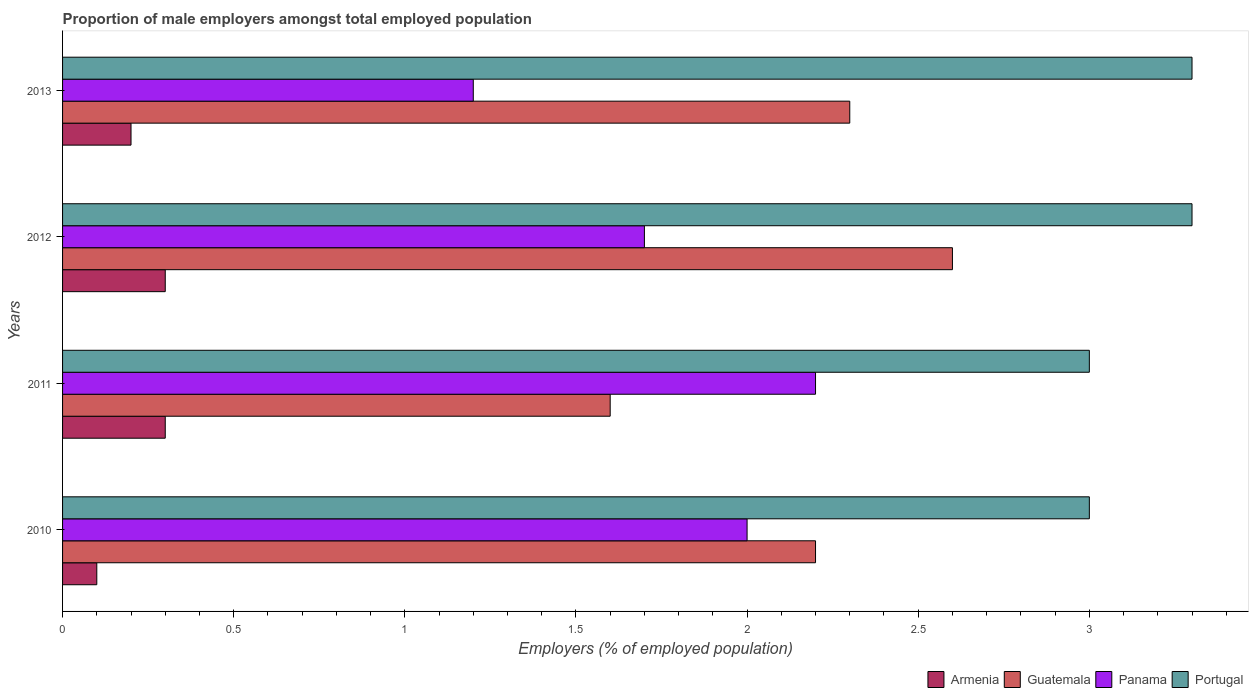Are the number of bars per tick equal to the number of legend labels?
Offer a terse response. Yes. How many bars are there on the 4th tick from the bottom?
Keep it short and to the point. 4. What is the proportion of male employers in Armenia in 2012?
Your answer should be compact. 0.3. Across all years, what is the maximum proportion of male employers in Portugal?
Make the answer very short. 3.3. Across all years, what is the minimum proportion of male employers in Panama?
Your answer should be compact. 1.2. In which year was the proportion of male employers in Armenia maximum?
Your answer should be very brief. 2011. In which year was the proportion of male employers in Panama minimum?
Give a very brief answer. 2013. What is the total proportion of male employers in Portugal in the graph?
Offer a terse response. 12.6. What is the difference between the proportion of male employers in Guatemala in 2011 and that in 2012?
Make the answer very short. -1. What is the difference between the proportion of male employers in Panama in 2011 and the proportion of male employers in Armenia in 2012?
Provide a succinct answer. 1.9. What is the average proportion of male employers in Armenia per year?
Make the answer very short. 0.23. In the year 2011, what is the difference between the proportion of male employers in Guatemala and proportion of male employers in Panama?
Give a very brief answer. -0.6. What is the ratio of the proportion of male employers in Armenia in 2012 to that in 2013?
Give a very brief answer. 1.5. Is the proportion of male employers in Portugal in 2011 less than that in 2013?
Offer a very short reply. Yes. What is the difference between the highest and the second highest proportion of male employers in Panama?
Provide a short and direct response. 0.2. What is the difference between the highest and the lowest proportion of male employers in Portugal?
Keep it short and to the point. 0.3. In how many years, is the proportion of male employers in Guatemala greater than the average proportion of male employers in Guatemala taken over all years?
Ensure brevity in your answer.  3. Is the sum of the proportion of male employers in Armenia in 2010 and 2012 greater than the maximum proportion of male employers in Guatemala across all years?
Make the answer very short. No. What does the 1st bar from the top in 2010 represents?
Your response must be concise. Portugal. What does the 3rd bar from the bottom in 2011 represents?
Offer a terse response. Panama. How many bars are there?
Your answer should be compact. 16. How many years are there in the graph?
Offer a terse response. 4. How many legend labels are there?
Offer a terse response. 4. How are the legend labels stacked?
Offer a very short reply. Horizontal. What is the title of the graph?
Make the answer very short. Proportion of male employers amongst total employed population. Does "Guam" appear as one of the legend labels in the graph?
Give a very brief answer. No. What is the label or title of the X-axis?
Your response must be concise. Employers (% of employed population). What is the Employers (% of employed population) in Armenia in 2010?
Ensure brevity in your answer.  0.1. What is the Employers (% of employed population) in Guatemala in 2010?
Give a very brief answer. 2.2. What is the Employers (% of employed population) in Panama in 2010?
Your answer should be very brief. 2. What is the Employers (% of employed population) of Armenia in 2011?
Ensure brevity in your answer.  0.3. What is the Employers (% of employed population) in Guatemala in 2011?
Make the answer very short. 1.6. What is the Employers (% of employed population) in Panama in 2011?
Offer a very short reply. 2.2. What is the Employers (% of employed population) of Armenia in 2012?
Offer a terse response. 0.3. What is the Employers (% of employed population) in Guatemala in 2012?
Your answer should be very brief. 2.6. What is the Employers (% of employed population) in Panama in 2012?
Make the answer very short. 1.7. What is the Employers (% of employed population) of Portugal in 2012?
Make the answer very short. 3.3. What is the Employers (% of employed population) in Armenia in 2013?
Offer a terse response. 0.2. What is the Employers (% of employed population) in Guatemala in 2013?
Provide a succinct answer. 2.3. What is the Employers (% of employed population) of Panama in 2013?
Provide a succinct answer. 1.2. What is the Employers (% of employed population) of Portugal in 2013?
Your answer should be very brief. 3.3. Across all years, what is the maximum Employers (% of employed population) of Armenia?
Offer a very short reply. 0.3. Across all years, what is the maximum Employers (% of employed population) of Guatemala?
Your answer should be compact. 2.6. Across all years, what is the maximum Employers (% of employed population) in Panama?
Provide a succinct answer. 2.2. Across all years, what is the maximum Employers (% of employed population) of Portugal?
Provide a succinct answer. 3.3. Across all years, what is the minimum Employers (% of employed population) in Armenia?
Give a very brief answer. 0.1. Across all years, what is the minimum Employers (% of employed population) of Guatemala?
Offer a very short reply. 1.6. Across all years, what is the minimum Employers (% of employed population) in Panama?
Offer a terse response. 1.2. What is the total Employers (% of employed population) in Guatemala in the graph?
Offer a very short reply. 8.7. What is the difference between the Employers (% of employed population) of Armenia in 2010 and that in 2012?
Offer a terse response. -0.2. What is the difference between the Employers (% of employed population) in Guatemala in 2010 and that in 2012?
Keep it short and to the point. -0.4. What is the difference between the Employers (% of employed population) in Panama in 2010 and that in 2012?
Your answer should be very brief. 0.3. What is the difference between the Employers (% of employed population) in Portugal in 2010 and that in 2012?
Keep it short and to the point. -0.3. What is the difference between the Employers (% of employed population) of Panama in 2010 and that in 2013?
Your answer should be very brief. 0.8. What is the difference between the Employers (% of employed population) of Portugal in 2010 and that in 2013?
Your answer should be compact. -0.3. What is the difference between the Employers (% of employed population) of Guatemala in 2011 and that in 2012?
Your answer should be compact. -1. What is the difference between the Employers (% of employed population) in Panama in 2011 and that in 2012?
Your response must be concise. 0.5. What is the difference between the Employers (% of employed population) of Portugal in 2011 and that in 2012?
Offer a terse response. -0.3. What is the difference between the Employers (% of employed population) in Guatemala in 2011 and that in 2013?
Ensure brevity in your answer.  -0.7. What is the difference between the Employers (% of employed population) in Portugal in 2011 and that in 2013?
Make the answer very short. -0.3. What is the difference between the Employers (% of employed population) of Armenia in 2012 and that in 2013?
Your answer should be compact. 0.1. What is the difference between the Employers (% of employed population) of Guatemala in 2012 and that in 2013?
Provide a short and direct response. 0.3. What is the difference between the Employers (% of employed population) in Armenia in 2010 and the Employers (% of employed population) in Panama in 2011?
Ensure brevity in your answer.  -2.1. What is the difference between the Employers (% of employed population) in Panama in 2010 and the Employers (% of employed population) in Portugal in 2011?
Offer a terse response. -1. What is the difference between the Employers (% of employed population) of Armenia in 2010 and the Employers (% of employed population) of Guatemala in 2012?
Provide a short and direct response. -2.5. What is the difference between the Employers (% of employed population) of Armenia in 2010 and the Employers (% of employed population) of Panama in 2012?
Offer a very short reply. -1.6. What is the difference between the Employers (% of employed population) of Guatemala in 2010 and the Employers (% of employed population) of Panama in 2012?
Provide a succinct answer. 0.5. What is the difference between the Employers (% of employed population) in Armenia in 2010 and the Employers (% of employed population) in Guatemala in 2013?
Ensure brevity in your answer.  -2.2. What is the difference between the Employers (% of employed population) of Armenia in 2010 and the Employers (% of employed population) of Panama in 2013?
Make the answer very short. -1.1. What is the difference between the Employers (% of employed population) in Guatemala in 2010 and the Employers (% of employed population) in Panama in 2013?
Ensure brevity in your answer.  1. What is the difference between the Employers (% of employed population) of Guatemala in 2010 and the Employers (% of employed population) of Portugal in 2013?
Provide a succinct answer. -1.1. What is the difference between the Employers (% of employed population) in Panama in 2010 and the Employers (% of employed population) in Portugal in 2013?
Offer a very short reply. -1.3. What is the difference between the Employers (% of employed population) of Guatemala in 2011 and the Employers (% of employed population) of Panama in 2012?
Your answer should be compact. -0.1. What is the difference between the Employers (% of employed population) in Guatemala in 2011 and the Employers (% of employed population) in Portugal in 2012?
Give a very brief answer. -1.7. What is the difference between the Employers (% of employed population) in Panama in 2011 and the Employers (% of employed population) in Portugal in 2012?
Your answer should be compact. -1.1. What is the difference between the Employers (% of employed population) of Armenia in 2011 and the Employers (% of employed population) of Portugal in 2013?
Keep it short and to the point. -3. What is the difference between the Employers (% of employed population) in Armenia in 2012 and the Employers (% of employed population) in Panama in 2013?
Your answer should be very brief. -0.9. What is the difference between the Employers (% of employed population) in Armenia in 2012 and the Employers (% of employed population) in Portugal in 2013?
Give a very brief answer. -3. What is the difference between the Employers (% of employed population) of Guatemala in 2012 and the Employers (% of employed population) of Panama in 2013?
Make the answer very short. 1.4. What is the difference between the Employers (% of employed population) in Panama in 2012 and the Employers (% of employed population) in Portugal in 2013?
Your answer should be very brief. -1.6. What is the average Employers (% of employed population) of Armenia per year?
Your response must be concise. 0.23. What is the average Employers (% of employed population) in Guatemala per year?
Your response must be concise. 2.17. What is the average Employers (% of employed population) of Panama per year?
Give a very brief answer. 1.77. What is the average Employers (% of employed population) of Portugal per year?
Provide a succinct answer. 3.15. In the year 2010, what is the difference between the Employers (% of employed population) of Armenia and Employers (% of employed population) of Guatemala?
Offer a very short reply. -2.1. In the year 2010, what is the difference between the Employers (% of employed population) in Guatemala and Employers (% of employed population) in Panama?
Your answer should be very brief. 0.2. In the year 2010, what is the difference between the Employers (% of employed population) in Guatemala and Employers (% of employed population) in Portugal?
Offer a very short reply. -0.8. In the year 2010, what is the difference between the Employers (% of employed population) in Panama and Employers (% of employed population) in Portugal?
Provide a succinct answer. -1. In the year 2011, what is the difference between the Employers (% of employed population) in Armenia and Employers (% of employed population) in Panama?
Keep it short and to the point. -1.9. In the year 2011, what is the difference between the Employers (% of employed population) in Guatemala and Employers (% of employed population) in Panama?
Your answer should be compact. -0.6. In the year 2011, what is the difference between the Employers (% of employed population) in Panama and Employers (% of employed population) in Portugal?
Give a very brief answer. -0.8. In the year 2012, what is the difference between the Employers (% of employed population) of Armenia and Employers (% of employed population) of Portugal?
Give a very brief answer. -3. In the year 2012, what is the difference between the Employers (% of employed population) of Guatemala and Employers (% of employed population) of Portugal?
Your answer should be very brief. -0.7. In the year 2013, what is the difference between the Employers (% of employed population) in Guatemala and Employers (% of employed population) in Portugal?
Give a very brief answer. -1. What is the ratio of the Employers (% of employed population) in Armenia in 2010 to that in 2011?
Your response must be concise. 0.33. What is the ratio of the Employers (% of employed population) in Guatemala in 2010 to that in 2011?
Your response must be concise. 1.38. What is the ratio of the Employers (% of employed population) of Guatemala in 2010 to that in 2012?
Offer a terse response. 0.85. What is the ratio of the Employers (% of employed population) of Panama in 2010 to that in 2012?
Your answer should be very brief. 1.18. What is the ratio of the Employers (% of employed population) of Portugal in 2010 to that in 2012?
Keep it short and to the point. 0.91. What is the ratio of the Employers (% of employed population) of Guatemala in 2010 to that in 2013?
Provide a short and direct response. 0.96. What is the ratio of the Employers (% of employed population) in Panama in 2010 to that in 2013?
Offer a terse response. 1.67. What is the ratio of the Employers (% of employed population) in Guatemala in 2011 to that in 2012?
Make the answer very short. 0.62. What is the ratio of the Employers (% of employed population) in Panama in 2011 to that in 2012?
Offer a terse response. 1.29. What is the ratio of the Employers (% of employed population) of Armenia in 2011 to that in 2013?
Provide a short and direct response. 1.5. What is the ratio of the Employers (% of employed population) of Guatemala in 2011 to that in 2013?
Your answer should be very brief. 0.7. What is the ratio of the Employers (% of employed population) in Panama in 2011 to that in 2013?
Offer a terse response. 1.83. What is the ratio of the Employers (% of employed population) of Armenia in 2012 to that in 2013?
Ensure brevity in your answer.  1.5. What is the ratio of the Employers (% of employed population) in Guatemala in 2012 to that in 2013?
Provide a short and direct response. 1.13. What is the ratio of the Employers (% of employed population) in Panama in 2012 to that in 2013?
Your answer should be very brief. 1.42. What is the ratio of the Employers (% of employed population) of Portugal in 2012 to that in 2013?
Offer a very short reply. 1. What is the difference between the highest and the second highest Employers (% of employed population) of Armenia?
Your response must be concise. 0. What is the difference between the highest and the second highest Employers (% of employed population) in Guatemala?
Keep it short and to the point. 0.3. What is the difference between the highest and the second highest Employers (% of employed population) of Panama?
Your response must be concise. 0.2. What is the difference between the highest and the lowest Employers (% of employed population) of Portugal?
Your answer should be compact. 0.3. 